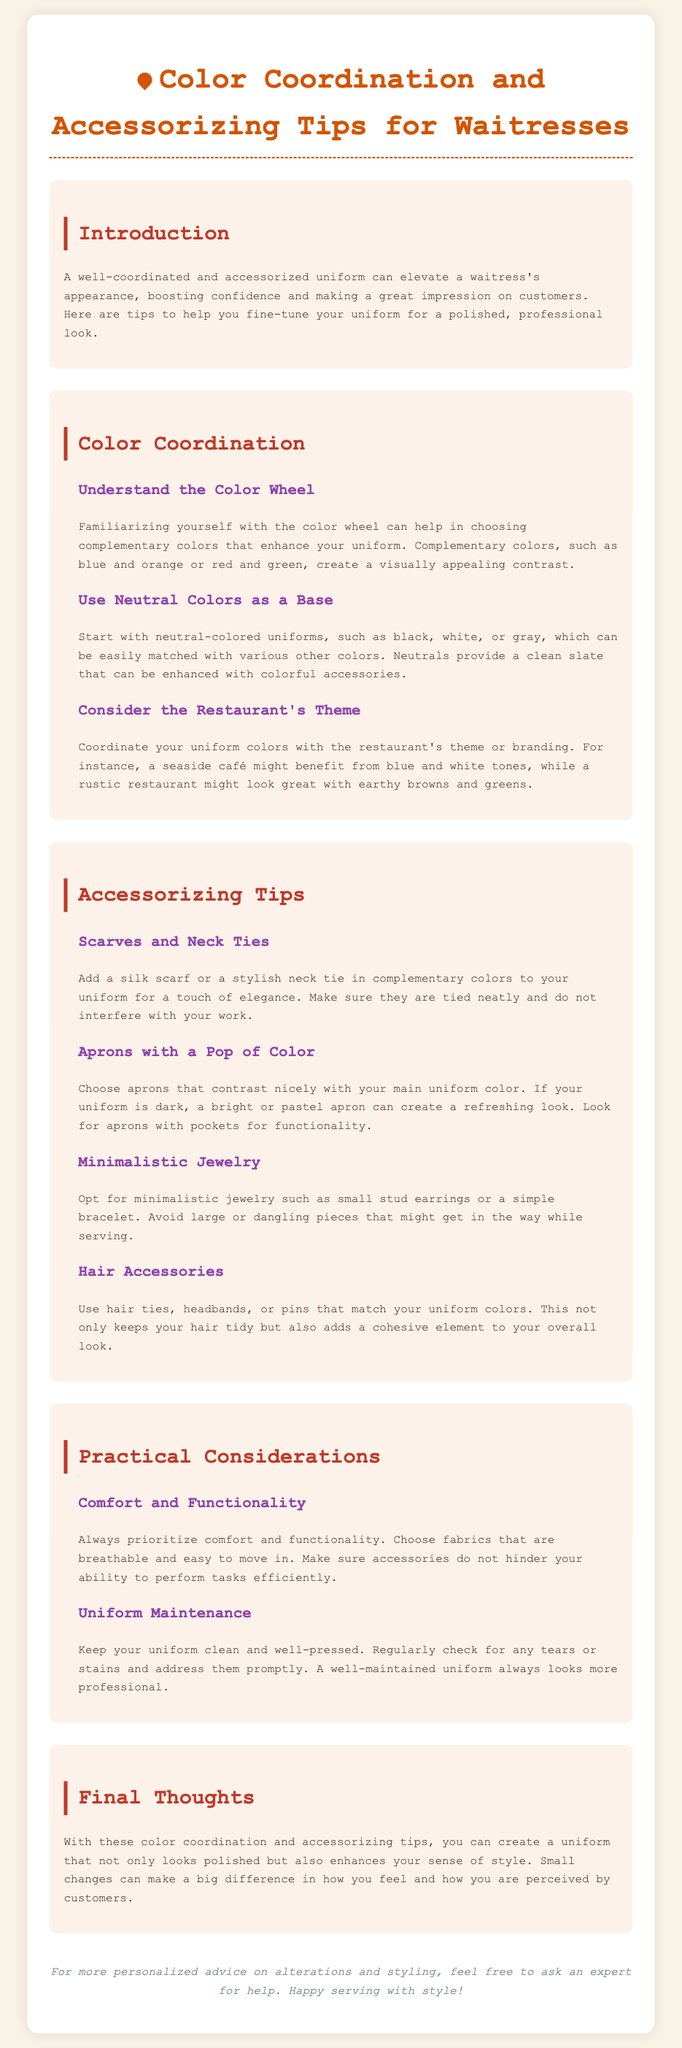what is the main focus of the document? The document focuses on tips for enhancing waitress uniforms through color coordination and accessorizing.
Answer: enhancing waitress uniforms what color combinations create visually appealing contrast? The document mentions complementary colors such as blue and orange or red and green.
Answer: blue and orange, red and green what is recommended as a base color for uniforms? The document suggests starting with neutral-colored uniforms, like black, white, or gray.
Answer: neutral-colored uniforms which accessory can add a touch of elegance? A silk scarf or stylish neck tie in complementary colors can add elegance to the uniform.
Answer: silk scarf or stylish neck tie what should be prioritized when selecting a uniform? Comfort and functionality are emphasized as priorities when choosing a uniform.
Answer: comfort and functionality how can aprons enhance the uniform? Choosing aprons that contrast nicely with the main uniform color adds a refreshing look.
Answer: contrast nicely what type of jewelry is recommended for waitresses? Minimalistic jewelry such as small stud earrings or a simple bracelet is recommended.
Answer: minimalistic jewelry how should a waitress maintain her uniform? The document advises keeping the uniform clean and well-pressed, checking for tears or stains.
Answer: clean and well-pressed what is the purpose of matching hair accessories? Matching hair accessories keeps hair tidy and adds a cohesive element to the uniform.
Answer: keeps hair tidy and cohesive 